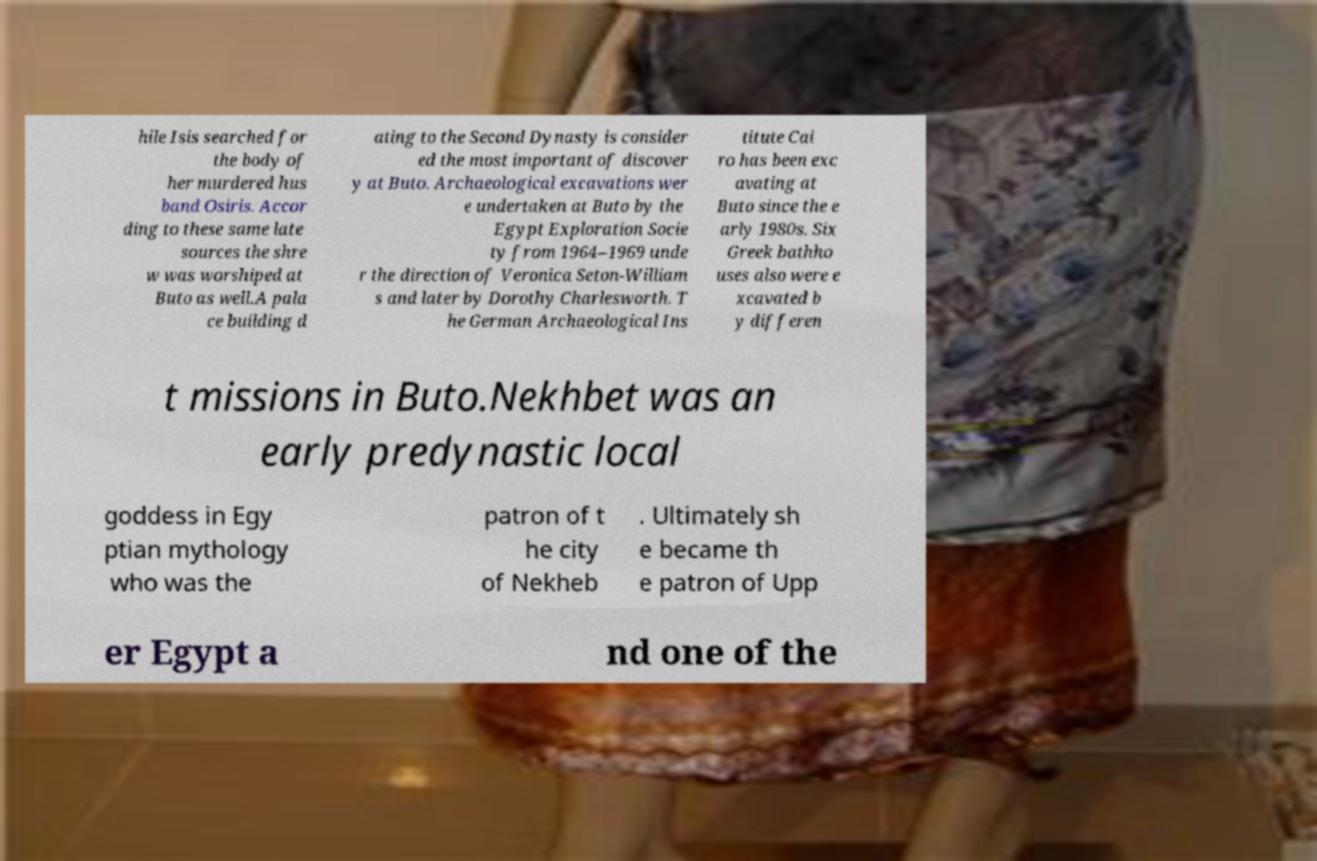For documentation purposes, I need the text within this image transcribed. Could you provide that? hile Isis searched for the body of her murdered hus band Osiris. Accor ding to these same late sources the shre w was worshiped at Buto as well.A pala ce building d ating to the Second Dynasty is consider ed the most important of discover y at Buto. Archaeological excavations wer e undertaken at Buto by the Egypt Exploration Socie ty from 1964–1969 unde r the direction of Veronica Seton-William s and later by Dorothy Charlesworth. T he German Archaeological Ins titute Cai ro has been exc avating at Buto since the e arly 1980s. Six Greek bathho uses also were e xcavated b y differen t missions in Buto.Nekhbet was an early predynastic local goddess in Egy ptian mythology who was the patron of t he city of Nekheb . Ultimately sh e became th e patron of Upp er Egypt a nd one of the 